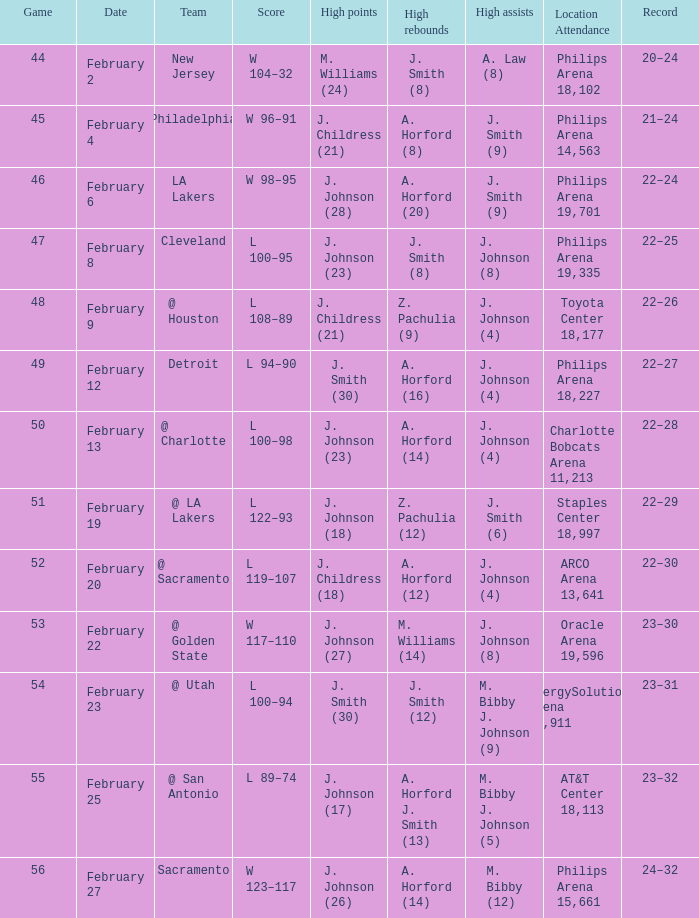What is the team positioned at philips arena 18,227? Detroit. 